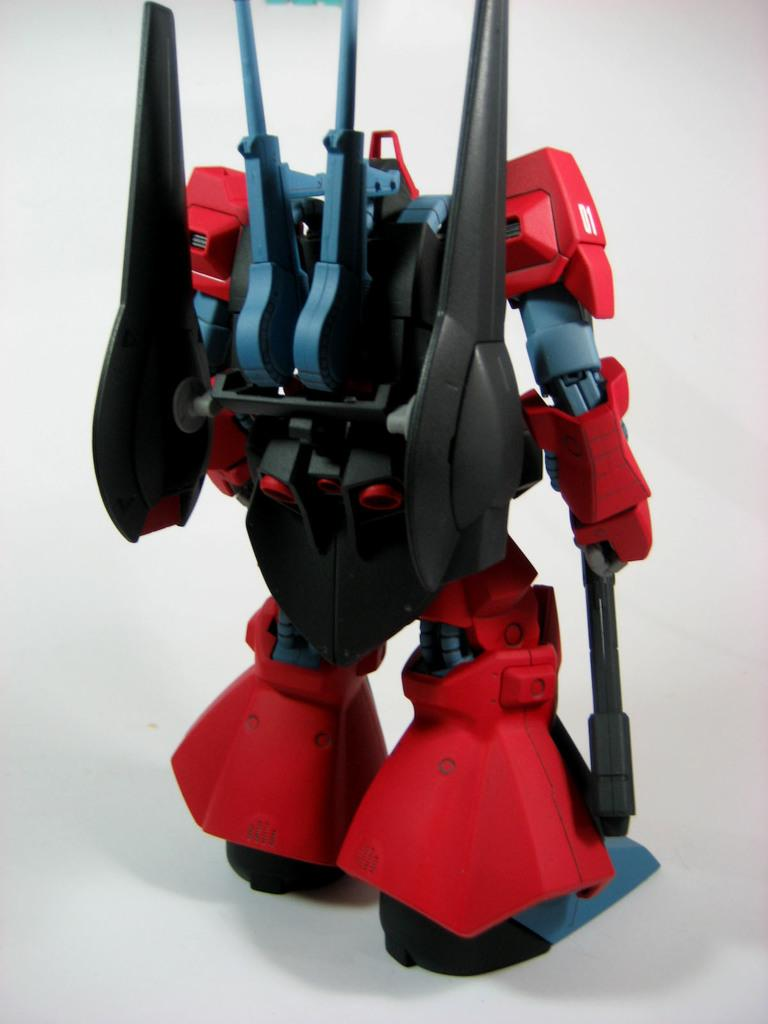What is the main subject of the image? There is a toy robot in the image. What color is the background of the image? The background of the image is white. Can you see any feathers on the toy robot in the image? There are no feathers present on the toy robot in the image. What type of act is the toy robot performing in the image? The toy robot is not performing any act in the image; it is simply a stationary object. 